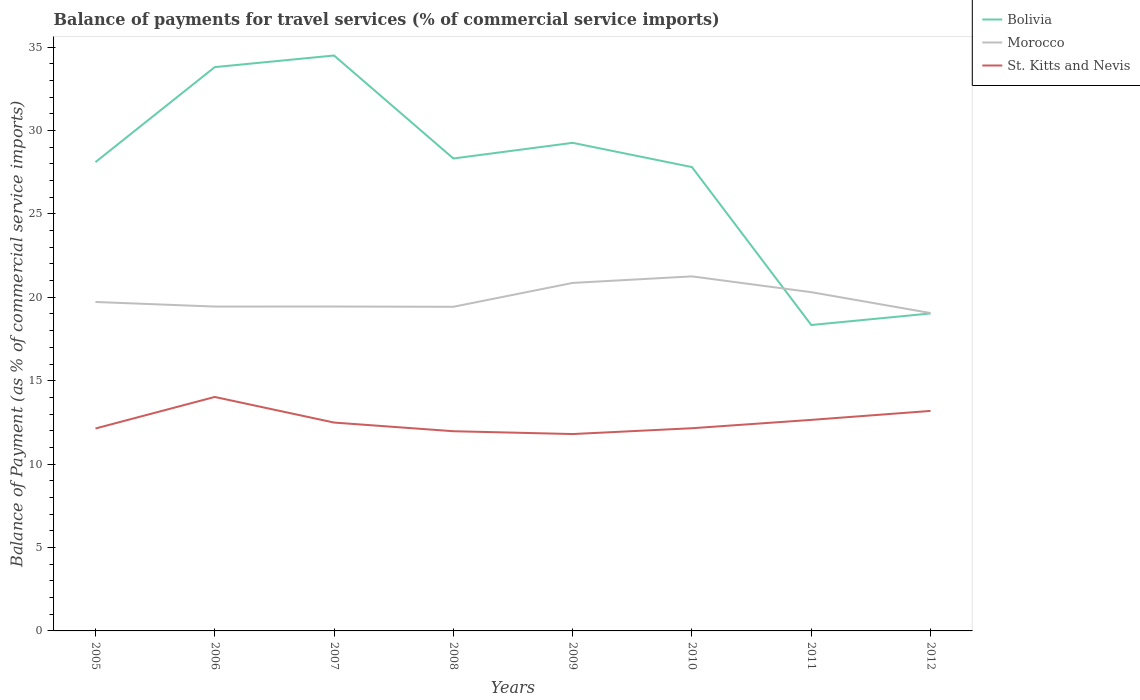Is the number of lines equal to the number of legend labels?
Your answer should be compact. Yes. Across all years, what is the maximum balance of payments for travel services in Bolivia?
Keep it short and to the point. 18.34. In which year was the balance of payments for travel services in St. Kitts and Nevis maximum?
Offer a terse response. 2009. What is the total balance of payments for travel services in Morocco in the graph?
Ensure brevity in your answer.  -0.86. What is the difference between the highest and the second highest balance of payments for travel services in St. Kitts and Nevis?
Offer a terse response. 2.22. What is the difference between the highest and the lowest balance of payments for travel services in St. Kitts and Nevis?
Keep it short and to the point. 3. What is the difference between two consecutive major ticks on the Y-axis?
Ensure brevity in your answer.  5. Are the values on the major ticks of Y-axis written in scientific E-notation?
Provide a short and direct response. No. Does the graph contain grids?
Keep it short and to the point. No. Where does the legend appear in the graph?
Ensure brevity in your answer.  Top right. How many legend labels are there?
Your answer should be compact. 3. How are the legend labels stacked?
Give a very brief answer. Vertical. What is the title of the graph?
Make the answer very short. Balance of payments for travel services (% of commercial service imports). Does "World" appear as one of the legend labels in the graph?
Your answer should be compact. No. What is the label or title of the X-axis?
Your response must be concise. Years. What is the label or title of the Y-axis?
Ensure brevity in your answer.  Balance of Payment (as % of commercial service imports). What is the Balance of Payment (as % of commercial service imports) of Bolivia in 2005?
Your answer should be compact. 28.1. What is the Balance of Payment (as % of commercial service imports) of Morocco in 2005?
Provide a succinct answer. 19.72. What is the Balance of Payment (as % of commercial service imports) of St. Kitts and Nevis in 2005?
Provide a short and direct response. 12.13. What is the Balance of Payment (as % of commercial service imports) in Bolivia in 2006?
Offer a very short reply. 33.8. What is the Balance of Payment (as % of commercial service imports) in Morocco in 2006?
Provide a succinct answer. 19.44. What is the Balance of Payment (as % of commercial service imports) in St. Kitts and Nevis in 2006?
Keep it short and to the point. 14.03. What is the Balance of Payment (as % of commercial service imports) of Bolivia in 2007?
Your answer should be compact. 34.49. What is the Balance of Payment (as % of commercial service imports) in Morocco in 2007?
Offer a very short reply. 19.45. What is the Balance of Payment (as % of commercial service imports) in St. Kitts and Nevis in 2007?
Provide a succinct answer. 12.49. What is the Balance of Payment (as % of commercial service imports) in Bolivia in 2008?
Your response must be concise. 28.32. What is the Balance of Payment (as % of commercial service imports) in Morocco in 2008?
Offer a terse response. 19.43. What is the Balance of Payment (as % of commercial service imports) of St. Kitts and Nevis in 2008?
Provide a short and direct response. 11.97. What is the Balance of Payment (as % of commercial service imports) in Bolivia in 2009?
Your answer should be compact. 29.26. What is the Balance of Payment (as % of commercial service imports) of Morocco in 2009?
Your answer should be compact. 20.86. What is the Balance of Payment (as % of commercial service imports) of St. Kitts and Nevis in 2009?
Ensure brevity in your answer.  11.8. What is the Balance of Payment (as % of commercial service imports) of Bolivia in 2010?
Ensure brevity in your answer.  27.8. What is the Balance of Payment (as % of commercial service imports) of Morocco in 2010?
Make the answer very short. 21.25. What is the Balance of Payment (as % of commercial service imports) in St. Kitts and Nevis in 2010?
Your response must be concise. 12.15. What is the Balance of Payment (as % of commercial service imports) in Bolivia in 2011?
Provide a succinct answer. 18.34. What is the Balance of Payment (as % of commercial service imports) in Morocco in 2011?
Offer a very short reply. 20.31. What is the Balance of Payment (as % of commercial service imports) in St. Kitts and Nevis in 2011?
Your answer should be very brief. 12.65. What is the Balance of Payment (as % of commercial service imports) of Bolivia in 2012?
Give a very brief answer. 19.03. What is the Balance of Payment (as % of commercial service imports) of Morocco in 2012?
Your response must be concise. 19.06. What is the Balance of Payment (as % of commercial service imports) in St. Kitts and Nevis in 2012?
Make the answer very short. 13.19. Across all years, what is the maximum Balance of Payment (as % of commercial service imports) of Bolivia?
Offer a very short reply. 34.49. Across all years, what is the maximum Balance of Payment (as % of commercial service imports) of Morocco?
Offer a terse response. 21.25. Across all years, what is the maximum Balance of Payment (as % of commercial service imports) of St. Kitts and Nevis?
Give a very brief answer. 14.03. Across all years, what is the minimum Balance of Payment (as % of commercial service imports) of Bolivia?
Offer a terse response. 18.34. Across all years, what is the minimum Balance of Payment (as % of commercial service imports) of Morocco?
Offer a very short reply. 19.06. Across all years, what is the minimum Balance of Payment (as % of commercial service imports) in St. Kitts and Nevis?
Make the answer very short. 11.8. What is the total Balance of Payment (as % of commercial service imports) in Bolivia in the graph?
Give a very brief answer. 219.15. What is the total Balance of Payment (as % of commercial service imports) in Morocco in the graph?
Give a very brief answer. 159.51. What is the total Balance of Payment (as % of commercial service imports) of St. Kitts and Nevis in the graph?
Make the answer very short. 100.41. What is the difference between the Balance of Payment (as % of commercial service imports) of Bolivia in 2005 and that in 2006?
Give a very brief answer. -5.69. What is the difference between the Balance of Payment (as % of commercial service imports) of Morocco in 2005 and that in 2006?
Offer a terse response. 0.27. What is the difference between the Balance of Payment (as % of commercial service imports) in St. Kitts and Nevis in 2005 and that in 2006?
Offer a very short reply. -1.89. What is the difference between the Balance of Payment (as % of commercial service imports) of Bolivia in 2005 and that in 2007?
Provide a short and direct response. -6.39. What is the difference between the Balance of Payment (as % of commercial service imports) of Morocco in 2005 and that in 2007?
Offer a very short reply. 0.27. What is the difference between the Balance of Payment (as % of commercial service imports) in St. Kitts and Nevis in 2005 and that in 2007?
Ensure brevity in your answer.  -0.36. What is the difference between the Balance of Payment (as % of commercial service imports) of Bolivia in 2005 and that in 2008?
Provide a short and direct response. -0.22. What is the difference between the Balance of Payment (as % of commercial service imports) of Morocco in 2005 and that in 2008?
Your answer should be compact. 0.29. What is the difference between the Balance of Payment (as % of commercial service imports) in St. Kitts and Nevis in 2005 and that in 2008?
Your answer should be very brief. 0.16. What is the difference between the Balance of Payment (as % of commercial service imports) in Bolivia in 2005 and that in 2009?
Provide a succinct answer. -1.15. What is the difference between the Balance of Payment (as % of commercial service imports) in Morocco in 2005 and that in 2009?
Your answer should be very brief. -1.14. What is the difference between the Balance of Payment (as % of commercial service imports) of Bolivia in 2005 and that in 2010?
Your answer should be compact. 0.3. What is the difference between the Balance of Payment (as % of commercial service imports) in Morocco in 2005 and that in 2010?
Offer a very short reply. -1.53. What is the difference between the Balance of Payment (as % of commercial service imports) in St. Kitts and Nevis in 2005 and that in 2010?
Give a very brief answer. -0.02. What is the difference between the Balance of Payment (as % of commercial service imports) in Bolivia in 2005 and that in 2011?
Your answer should be very brief. 9.77. What is the difference between the Balance of Payment (as % of commercial service imports) of Morocco in 2005 and that in 2011?
Your answer should be compact. -0.59. What is the difference between the Balance of Payment (as % of commercial service imports) of St. Kitts and Nevis in 2005 and that in 2011?
Offer a very short reply. -0.52. What is the difference between the Balance of Payment (as % of commercial service imports) in Bolivia in 2005 and that in 2012?
Offer a very short reply. 9.07. What is the difference between the Balance of Payment (as % of commercial service imports) in Morocco in 2005 and that in 2012?
Offer a terse response. 0.66. What is the difference between the Balance of Payment (as % of commercial service imports) in St. Kitts and Nevis in 2005 and that in 2012?
Your answer should be very brief. -1.05. What is the difference between the Balance of Payment (as % of commercial service imports) of Bolivia in 2006 and that in 2007?
Your answer should be compact. -0.7. What is the difference between the Balance of Payment (as % of commercial service imports) of Morocco in 2006 and that in 2007?
Give a very brief answer. -0. What is the difference between the Balance of Payment (as % of commercial service imports) in St. Kitts and Nevis in 2006 and that in 2007?
Give a very brief answer. 1.53. What is the difference between the Balance of Payment (as % of commercial service imports) in Bolivia in 2006 and that in 2008?
Your response must be concise. 5.48. What is the difference between the Balance of Payment (as % of commercial service imports) in Morocco in 2006 and that in 2008?
Give a very brief answer. 0.01. What is the difference between the Balance of Payment (as % of commercial service imports) of St. Kitts and Nevis in 2006 and that in 2008?
Your answer should be very brief. 2.05. What is the difference between the Balance of Payment (as % of commercial service imports) of Bolivia in 2006 and that in 2009?
Your answer should be compact. 4.54. What is the difference between the Balance of Payment (as % of commercial service imports) in Morocco in 2006 and that in 2009?
Keep it short and to the point. -1.42. What is the difference between the Balance of Payment (as % of commercial service imports) in St. Kitts and Nevis in 2006 and that in 2009?
Ensure brevity in your answer.  2.22. What is the difference between the Balance of Payment (as % of commercial service imports) in Bolivia in 2006 and that in 2010?
Ensure brevity in your answer.  5.99. What is the difference between the Balance of Payment (as % of commercial service imports) in Morocco in 2006 and that in 2010?
Your answer should be compact. -1.81. What is the difference between the Balance of Payment (as % of commercial service imports) in St. Kitts and Nevis in 2006 and that in 2010?
Your response must be concise. 1.87. What is the difference between the Balance of Payment (as % of commercial service imports) in Bolivia in 2006 and that in 2011?
Offer a very short reply. 15.46. What is the difference between the Balance of Payment (as % of commercial service imports) of Morocco in 2006 and that in 2011?
Give a very brief answer. -0.86. What is the difference between the Balance of Payment (as % of commercial service imports) of St. Kitts and Nevis in 2006 and that in 2011?
Your answer should be very brief. 1.37. What is the difference between the Balance of Payment (as % of commercial service imports) in Bolivia in 2006 and that in 2012?
Offer a terse response. 14.77. What is the difference between the Balance of Payment (as % of commercial service imports) of Morocco in 2006 and that in 2012?
Provide a succinct answer. 0.39. What is the difference between the Balance of Payment (as % of commercial service imports) in St. Kitts and Nevis in 2006 and that in 2012?
Your response must be concise. 0.84. What is the difference between the Balance of Payment (as % of commercial service imports) in Bolivia in 2007 and that in 2008?
Make the answer very short. 6.17. What is the difference between the Balance of Payment (as % of commercial service imports) of Morocco in 2007 and that in 2008?
Your answer should be very brief. 0.02. What is the difference between the Balance of Payment (as % of commercial service imports) in St. Kitts and Nevis in 2007 and that in 2008?
Make the answer very short. 0.52. What is the difference between the Balance of Payment (as % of commercial service imports) of Bolivia in 2007 and that in 2009?
Keep it short and to the point. 5.24. What is the difference between the Balance of Payment (as % of commercial service imports) of Morocco in 2007 and that in 2009?
Provide a short and direct response. -1.42. What is the difference between the Balance of Payment (as % of commercial service imports) in St. Kitts and Nevis in 2007 and that in 2009?
Your answer should be very brief. 0.69. What is the difference between the Balance of Payment (as % of commercial service imports) in Bolivia in 2007 and that in 2010?
Ensure brevity in your answer.  6.69. What is the difference between the Balance of Payment (as % of commercial service imports) of Morocco in 2007 and that in 2010?
Your answer should be compact. -1.81. What is the difference between the Balance of Payment (as % of commercial service imports) of St. Kitts and Nevis in 2007 and that in 2010?
Your response must be concise. 0.34. What is the difference between the Balance of Payment (as % of commercial service imports) of Bolivia in 2007 and that in 2011?
Ensure brevity in your answer.  16.15. What is the difference between the Balance of Payment (as % of commercial service imports) in Morocco in 2007 and that in 2011?
Keep it short and to the point. -0.86. What is the difference between the Balance of Payment (as % of commercial service imports) of St. Kitts and Nevis in 2007 and that in 2011?
Your answer should be compact. -0.16. What is the difference between the Balance of Payment (as % of commercial service imports) in Bolivia in 2007 and that in 2012?
Your answer should be very brief. 15.46. What is the difference between the Balance of Payment (as % of commercial service imports) in Morocco in 2007 and that in 2012?
Provide a short and direct response. 0.39. What is the difference between the Balance of Payment (as % of commercial service imports) in St. Kitts and Nevis in 2007 and that in 2012?
Offer a terse response. -0.7. What is the difference between the Balance of Payment (as % of commercial service imports) of Bolivia in 2008 and that in 2009?
Offer a terse response. -0.94. What is the difference between the Balance of Payment (as % of commercial service imports) of Morocco in 2008 and that in 2009?
Ensure brevity in your answer.  -1.43. What is the difference between the Balance of Payment (as % of commercial service imports) in St. Kitts and Nevis in 2008 and that in 2009?
Your response must be concise. 0.17. What is the difference between the Balance of Payment (as % of commercial service imports) in Bolivia in 2008 and that in 2010?
Your answer should be compact. 0.52. What is the difference between the Balance of Payment (as % of commercial service imports) in Morocco in 2008 and that in 2010?
Provide a short and direct response. -1.82. What is the difference between the Balance of Payment (as % of commercial service imports) in St. Kitts and Nevis in 2008 and that in 2010?
Offer a terse response. -0.18. What is the difference between the Balance of Payment (as % of commercial service imports) in Bolivia in 2008 and that in 2011?
Your answer should be very brief. 9.98. What is the difference between the Balance of Payment (as % of commercial service imports) in Morocco in 2008 and that in 2011?
Keep it short and to the point. -0.88. What is the difference between the Balance of Payment (as % of commercial service imports) of St. Kitts and Nevis in 2008 and that in 2011?
Provide a short and direct response. -0.68. What is the difference between the Balance of Payment (as % of commercial service imports) of Bolivia in 2008 and that in 2012?
Your answer should be very brief. 9.29. What is the difference between the Balance of Payment (as % of commercial service imports) of Morocco in 2008 and that in 2012?
Provide a short and direct response. 0.37. What is the difference between the Balance of Payment (as % of commercial service imports) in St. Kitts and Nevis in 2008 and that in 2012?
Give a very brief answer. -1.22. What is the difference between the Balance of Payment (as % of commercial service imports) in Bolivia in 2009 and that in 2010?
Provide a succinct answer. 1.45. What is the difference between the Balance of Payment (as % of commercial service imports) of Morocco in 2009 and that in 2010?
Provide a succinct answer. -0.39. What is the difference between the Balance of Payment (as % of commercial service imports) in St. Kitts and Nevis in 2009 and that in 2010?
Offer a terse response. -0.35. What is the difference between the Balance of Payment (as % of commercial service imports) of Bolivia in 2009 and that in 2011?
Keep it short and to the point. 10.92. What is the difference between the Balance of Payment (as % of commercial service imports) in Morocco in 2009 and that in 2011?
Your answer should be very brief. 0.55. What is the difference between the Balance of Payment (as % of commercial service imports) of St. Kitts and Nevis in 2009 and that in 2011?
Your answer should be very brief. -0.85. What is the difference between the Balance of Payment (as % of commercial service imports) in Bolivia in 2009 and that in 2012?
Ensure brevity in your answer.  10.23. What is the difference between the Balance of Payment (as % of commercial service imports) in Morocco in 2009 and that in 2012?
Give a very brief answer. 1.8. What is the difference between the Balance of Payment (as % of commercial service imports) in St. Kitts and Nevis in 2009 and that in 2012?
Your answer should be compact. -1.39. What is the difference between the Balance of Payment (as % of commercial service imports) in Bolivia in 2010 and that in 2011?
Make the answer very short. 9.47. What is the difference between the Balance of Payment (as % of commercial service imports) in Morocco in 2010 and that in 2011?
Ensure brevity in your answer.  0.95. What is the difference between the Balance of Payment (as % of commercial service imports) of Bolivia in 2010 and that in 2012?
Offer a terse response. 8.77. What is the difference between the Balance of Payment (as % of commercial service imports) in Morocco in 2010 and that in 2012?
Offer a terse response. 2.2. What is the difference between the Balance of Payment (as % of commercial service imports) of St. Kitts and Nevis in 2010 and that in 2012?
Your answer should be very brief. -1.04. What is the difference between the Balance of Payment (as % of commercial service imports) in Bolivia in 2011 and that in 2012?
Give a very brief answer. -0.69. What is the difference between the Balance of Payment (as % of commercial service imports) of Morocco in 2011 and that in 2012?
Offer a terse response. 1.25. What is the difference between the Balance of Payment (as % of commercial service imports) in St. Kitts and Nevis in 2011 and that in 2012?
Offer a terse response. -0.54. What is the difference between the Balance of Payment (as % of commercial service imports) of Bolivia in 2005 and the Balance of Payment (as % of commercial service imports) of Morocco in 2006?
Offer a terse response. 8.66. What is the difference between the Balance of Payment (as % of commercial service imports) of Bolivia in 2005 and the Balance of Payment (as % of commercial service imports) of St. Kitts and Nevis in 2006?
Provide a short and direct response. 14.08. What is the difference between the Balance of Payment (as % of commercial service imports) of Morocco in 2005 and the Balance of Payment (as % of commercial service imports) of St. Kitts and Nevis in 2006?
Your answer should be very brief. 5.69. What is the difference between the Balance of Payment (as % of commercial service imports) of Bolivia in 2005 and the Balance of Payment (as % of commercial service imports) of Morocco in 2007?
Your answer should be compact. 8.66. What is the difference between the Balance of Payment (as % of commercial service imports) in Bolivia in 2005 and the Balance of Payment (as % of commercial service imports) in St. Kitts and Nevis in 2007?
Your answer should be very brief. 15.61. What is the difference between the Balance of Payment (as % of commercial service imports) in Morocco in 2005 and the Balance of Payment (as % of commercial service imports) in St. Kitts and Nevis in 2007?
Offer a terse response. 7.23. What is the difference between the Balance of Payment (as % of commercial service imports) of Bolivia in 2005 and the Balance of Payment (as % of commercial service imports) of Morocco in 2008?
Give a very brief answer. 8.67. What is the difference between the Balance of Payment (as % of commercial service imports) of Bolivia in 2005 and the Balance of Payment (as % of commercial service imports) of St. Kitts and Nevis in 2008?
Give a very brief answer. 16.13. What is the difference between the Balance of Payment (as % of commercial service imports) of Morocco in 2005 and the Balance of Payment (as % of commercial service imports) of St. Kitts and Nevis in 2008?
Your response must be concise. 7.75. What is the difference between the Balance of Payment (as % of commercial service imports) of Bolivia in 2005 and the Balance of Payment (as % of commercial service imports) of Morocco in 2009?
Make the answer very short. 7.24. What is the difference between the Balance of Payment (as % of commercial service imports) in Bolivia in 2005 and the Balance of Payment (as % of commercial service imports) in St. Kitts and Nevis in 2009?
Keep it short and to the point. 16.3. What is the difference between the Balance of Payment (as % of commercial service imports) of Morocco in 2005 and the Balance of Payment (as % of commercial service imports) of St. Kitts and Nevis in 2009?
Give a very brief answer. 7.92. What is the difference between the Balance of Payment (as % of commercial service imports) of Bolivia in 2005 and the Balance of Payment (as % of commercial service imports) of Morocco in 2010?
Give a very brief answer. 6.85. What is the difference between the Balance of Payment (as % of commercial service imports) of Bolivia in 2005 and the Balance of Payment (as % of commercial service imports) of St. Kitts and Nevis in 2010?
Your answer should be compact. 15.95. What is the difference between the Balance of Payment (as % of commercial service imports) in Morocco in 2005 and the Balance of Payment (as % of commercial service imports) in St. Kitts and Nevis in 2010?
Your answer should be compact. 7.57. What is the difference between the Balance of Payment (as % of commercial service imports) of Bolivia in 2005 and the Balance of Payment (as % of commercial service imports) of Morocco in 2011?
Offer a terse response. 7.8. What is the difference between the Balance of Payment (as % of commercial service imports) of Bolivia in 2005 and the Balance of Payment (as % of commercial service imports) of St. Kitts and Nevis in 2011?
Your response must be concise. 15.45. What is the difference between the Balance of Payment (as % of commercial service imports) of Morocco in 2005 and the Balance of Payment (as % of commercial service imports) of St. Kitts and Nevis in 2011?
Your answer should be compact. 7.07. What is the difference between the Balance of Payment (as % of commercial service imports) in Bolivia in 2005 and the Balance of Payment (as % of commercial service imports) in Morocco in 2012?
Offer a terse response. 9.05. What is the difference between the Balance of Payment (as % of commercial service imports) of Bolivia in 2005 and the Balance of Payment (as % of commercial service imports) of St. Kitts and Nevis in 2012?
Your response must be concise. 14.92. What is the difference between the Balance of Payment (as % of commercial service imports) of Morocco in 2005 and the Balance of Payment (as % of commercial service imports) of St. Kitts and Nevis in 2012?
Your response must be concise. 6.53. What is the difference between the Balance of Payment (as % of commercial service imports) of Bolivia in 2006 and the Balance of Payment (as % of commercial service imports) of Morocco in 2007?
Your answer should be very brief. 14.35. What is the difference between the Balance of Payment (as % of commercial service imports) in Bolivia in 2006 and the Balance of Payment (as % of commercial service imports) in St. Kitts and Nevis in 2007?
Ensure brevity in your answer.  21.31. What is the difference between the Balance of Payment (as % of commercial service imports) in Morocco in 2006 and the Balance of Payment (as % of commercial service imports) in St. Kitts and Nevis in 2007?
Ensure brevity in your answer.  6.95. What is the difference between the Balance of Payment (as % of commercial service imports) of Bolivia in 2006 and the Balance of Payment (as % of commercial service imports) of Morocco in 2008?
Provide a succinct answer. 14.37. What is the difference between the Balance of Payment (as % of commercial service imports) of Bolivia in 2006 and the Balance of Payment (as % of commercial service imports) of St. Kitts and Nevis in 2008?
Your response must be concise. 21.83. What is the difference between the Balance of Payment (as % of commercial service imports) in Morocco in 2006 and the Balance of Payment (as % of commercial service imports) in St. Kitts and Nevis in 2008?
Offer a terse response. 7.47. What is the difference between the Balance of Payment (as % of commercial service imports) in Bolivia in 2006 and the Balance of Payment (as % of commercial service imports) in Morocco in 2009?
Offer a terse response. 12.94. What is the difference between the Balance of Payment (as % of commercial service imports) in Bolivia in 2006 and the Balance of Payment (as % of commercial service imports) in St. Kitts and Nevis in 2009?
Your answer should be compact. 22. What is the difference between the Balance of Payment (as % of commercial service imports) in Morocco in 2006 and the Balance of Payment (as % of commercial service imports) in St. Kitts and Nevis in 2009?
Your response must be concise. 7.64. What is the difference between the Balance of Payment (as % of commercial service imports) of Bolivia in 2006 and the Balance of Payment (as % of commercial service imports) of Morocco in 2010?
Give a very brief answer. 12.54. What is the difference between the Balance of Payment (as % of commercial service imports) in Bolivia in 2006 and the Balance of Payment (as % of commercial service imports) in St. Kitts and Nevis in 2010?
Offer a terse response. 21.65. What is the difference between the Balance of Payment (as % of commercial service imports) in Morocco in 2006 and the Balance of Payment (as % of commercial service imports) in St. Kitts and Nevis in 2010?
Keep it short and to the point. 7.29. What is the difference between the Balance of Payment (as % of commercial service imports) of Bolivia in 2006 and the Balance of Payment (as % of commercial service imports) of Morocco in 2011?
Provide a short and direct response. 13.49. What is the difference between the Balance of Payment (as % of commercial service imports) in Bolivia in 2006 and the Balance of Payment (as % of commercial service imports) in St. Kitts and Nevis in 2011?
Provide a short and direct response. 21.15. What is the difference between the Balance of Payment (as % of commercial service imports) of Morocco in 2006 and the Balance of Payment (as % of commercial service imports) of St. Kitts and Nevis in 2011?
Ensure brevity in your answer.  6.79. What is the difference between the Balance of Payment (as % of commercial service imports) of Bolivia in 2006 and the Balance of Payment (as % of commercial service imports) of Morocco in 2012?
Give a very brief answer. 14.74. What is the difference between the Balance of Payment (as % of commercial service imports) of Bolivia in 2006 and the Balance of Payment (as % of commercial service imports) of St. Kitts and Nevis in 2012?
Give a very brief answer. 20.61. What is the difference between the Balance of Payment (as % of commercial service imports) in Morocco in 2006 and the Balance of Payment (as % of commercial service imports) in St. Kitts and Nevis in 2012?
Your answer should be compact. 6.26. What is the difference between the Balance of Payment (as % of commercial service imports) of Bolivia in 2007 and the Balance of Payment (as % of commercial service imports) of Morocco in 2008?
Offer a terse response. 15.06. What is the difference between the Balance of Payment (as % of commercial service imports) of Bolivia in 2007 and the Balance of Payment (as % of commercial service imports) of St. Kitts and Nevis in 2008?
Provide a short and direct response. 22.52. What is the difference between the Balance of Payment (as % of commercial service imports) of Morocco in 2007 and the Balance of Payment (as % of commercial service imports) of St. Kitts and Nevis in 2008?
Your answer should be compact. 7.47. What is the difference between the Balance of Payment (as % of commercial service imports) in Bolivia in 2007 and the Balance of Payment (as % of commercial service imports) in Morocco in 2009?
Your response must be concise. 13.63. What is the difference between the Balance of Payment (as % of commercial service imports) of Bolivia in 2007 and the Balance of Payment (as % of commercial service imports) of St. Kitts and Nevis in 2009?
Provide a short and direct response. 22.69. What is the difference between the Balance of Payment (as % of commercial service imports) of Morocco in 2007 and the Balance of Payment (as % of commercial service imports) of St. Kitts and Nevis in 2009?
Offer a very short reply. 7.64. What is the difference between the Balance of Payment (as % of commercial service imports) in Bolivia in 2007 and the Balance of Payment (as % of commercial service imports) in Morocco in 2010?
Your answer should be very brief. 13.24. What is the difference between the Balance of Payment (as % of commercial service imports) of Bolivia in 2007 and the Balance of Payment (as % of commercial service imports) of St. Kitts and Nevis in 2010?
Keep it short and to the point. 22.34. What is the difference between the Balance of Payment (as % of commercial service imports) in Morocco in 2007 and the Balance of Payment (as % of commercial service imports) in St. Kitts and Nevis in 2010?
Make the answer very short. 7.29. What is the difference between the Balance of Payment (as % of commercial service imports) in Bolivia in 2007 and the Balance of Payment (as % of commercial service imports) in Morocco in 2011?
Offer a very short reply. 14.19. What is the difference between the Balance of Payment (as % of commercial service imports) in Bolivia in 2007 and the Balance of Payment (as % of commercial service imports) in St. Kitts and Nevis in 2011?
Your response must be concise. 21.84. What is the difference between the Balance of Payment (as % of commercial service imports) in Morocco in 2007 and the Balance of Payment (as % of commercial service imports) in St. Kitts and Nevis in 2011?
Your response must be concise. 6.79. What is the difference between the Balance of Payment (as % of commercial service imports) of Bolivia in 2007 and the Balance of Payment (as % of commercial service imports) of Morocco in 2012?
Your response must be concise. 15.44. What is the difference between the Balance of Payment (as % of commercial service imports) of Bolivia in 2007 and the Balance of Payment (as % of commercial service imports) of St. Kitts and Nevis in 2012?
Provide a succinct answer. 21.31. What is the difference between the Balance of Payment (as % of commercial service imports) of Morocco in 2007 and the Balance of Payment (as % of commercial service imports) of St. Kitts and Nevis in 2012?
Offer a very short reply. 6.26. What is the difference between the Balance of Payment (as % of commercial service imports) of Bolivia in 2008 and the Balance of Payment (as % of commercial service imports) of Morocco in 2009?
Provide a short and direct response. 7.46. What is the difference between the Balance of Payment (as % of commercial service imports) in Bolivia in 2008 and the Balance of Payment (as % of commercial service imports) in St. Kitts and Nevis in 2009?
Keep it short and to the point. 16.52. What is the difference between the Balance of Payment (as % of commercial service imports) in Morocco in 2008 and the Balance of Payment (as % of commercial service imports) in St. Kitts and Nevis in 2009?
Provide a short and direct response. 7.63. What is the difference between the Balance of Payment (as % of commercial service imports) of Bolivia in 2008 and the Balance of Payment (as % of commercial service imports) of Morocco in 2010?
Offer a very short reply. 7.07. What is the difference between the Balance of Payment (as % of commercial service imports) of Bolivia in 2008 and the Balance of Payment (as % of commercial service imports) of St. Kitts and Nevis in 2010?
Offer a terse response. 16.17. What is the difference between the Balance of Payment (as % of commercial service imports) in Morocco in 2008 and the Balance of Payment (as % of commercial service imports) in St. Kitts and Nevis in 2010?
Your response must be concise. 7.28. What is the difference between the Balance of Payment (as % of commercial service imports) of Bolivia in 2008 and the Balance of Payment (as % of commercial service imports) of Morocco in 2011?
Keep it short and to the point. 8.01. What is the difference between the Balance of Payment (as % of commercial service imports) in Bolivia in 2008 and the Balance of Payment (as % of commercial service imports) in St. Kitts and Nevis in 2011?
Make the answer very short. 15.67. What is the difference between the Balance of Payment (as % of commercial service imports) in Morocco in 2008 and the Balance of Payment (as % of commercial service imports) in St. Kitts and Nevis in 2011?
Provide a succinct answer. 6.78. What is the difference between the Balance of Payment (as % of commercial service imports) of Bolivia in 2008 and the Balance of Payment (as % of commercial service imports) of Morocco in 2012?
Offer a very short reply. 9.26. What is the difference between the Balance of Payment (as % of commercial service imports) in Bolivia in 2008 and the Balance of Payment (as % of commercial service imports) in St. Kitts and Nevis in 2012?
Provide a short and direct response. 15.13. What is the difference between the Balance of Payment (as % of commercial service imports) in Morocco in 2008 and the Balance of Payment (as % of commercial service imports) in St. Kitts and Nevis in 2012?
Make the answer very short. 6.24. What is the difference between the Balance of Payment (as % of commercial service imports) in Bolivia in 2009 and the Balance of Payment (as % of commercial service imports) in Morocco in 2010?
Your answer should be compact. 8.01. What is the difference between the Balance of Payment (as % of commercial service imports) in Bolivia in 2009 and the Balance of Payment (as % of commercial service imports) in St. Kitts and Nevis in 2010?
Keep it short and to the point. 17.11. What is the difference between the Balance of Payment (as % of commercial service imports) in Morocco in 2009 and the Balance of Payment (as % of commercial service imports) in St. Kitts and Nevis in 2010?
Provide a short and direct response. 8.71. What is the difference between the Balance of Payment (as % of commercial service imports) in Bolivia in 2009 and the Balance of Payment (as % of commercial service imports) in Morocco in 2011?
Keep it short and to the point. 8.95. What is the difference between the Balance of Payment (as % of commercial service imports) of Bolivia in 2009 and the Balance of Payment (as % of commercial service imports) of St. Kitts and Nevis in 2011?
Make the answer very short. 16.61. What is the difference between the Balance of Payment (as % of commercial service imports) of Morocco in 2009 and the Balance of Payment (as % of commercial service imports) of St. Kitts and Nevis in 2011?
Offer a very short reply. 8.21. What is the difference between the Balance of Payment (as % of commercial service imports) of Bolivia in 2009 and the Balance of Payment (as % of commercial service imports) of Morocco in 2012?
Offer a terse response. 10.2. What is the difference between the Balance of Payment (as % of commercial service imports) in Bolivia in 2009 and the Balance of Payment (as % of commercial service imports) in St. Kitts and Nevis in 2012?
Keep it short and to the point. 16.07. What is the difference between the Balance of Payment (as % of commercial service imports) in Morocco in 2009 and the Balance of Payment (as % of commercial service imports) in St. Kitts and Nevis in 2012?
Ensure brevity in your answer.  7.67. What is the difference between the Balance of Payment (as % of commercial service imports) of Bolivia in 2010 and the Balance of Payment (as % of commercial service imports) of Morocco in 2011?
Offer a very short reply. 7.5. What is the difference between the Balance of Payment (as % of commercial service imports) in Bolivia in 2010 and the Balance of Payment (as % of commercial service imports) in St. Kitts and Nevis in 2011?
Make the answer very short. 15.15. What is the difference between the Balance of Payment (as % of commercial service imports) of Morocco in 2010 and the Balance of Payment (as % of commercial service imports) of St. Kitts and Nevis in 2011?
Give a very brief answer. 8.6. What is the difference between the Balance of Payment (as % of commercial service imports) of Bolivia in 2010 and the Balance of Payment (as % of commercial service imports) of Morocco in 2012?
Ensure brevity in your answer.  8.75. What is the difference between the Balance of Payment (as % of commercial service imports) of Bolivia in 2010 and the Balance of Payment (as % of commercial service imports) of St. Kitts and Nevis in 2012?
Your answer should be compact. 14.62. What is the difference between the Balance of Payment (as % of commercial service imports) of Morocco in 2010 and the Balance of Payment (as % of commercial service imports) of St. Kitts and Nevis in 2012?
Give a very brief answer. 8.06. What is the difference between the Balance of Payment (as % of commercial service imports) of Bolivia in 2011 and the Balance of Payment (as % of commercial service imports) of Morocco in 2012?
Give a very brief answer. -0.72. What is the difference between the Balance of Payment (as % of commercial service imports) in Bolivia in 2011 and the Balance of Payment (as % of commercial service imports) in St. Kitts and Nevis in 2012?
Your response must be concise. 5.15. What is the difference between the Balance of Payment (as % of commercial service imports) of Morocco in 2011 and the Balance of Payment (as % of commercial service imports) of St. Kitts and Nevis in 2012?
Offer a very short reply. 7.12. What is the average Balance of Payment (as % of commercial service imports) of Bolivia per year?
Provide a succinct answer. 27.39. What is the average Balance of Payment (as % of commercial service imports) of Morocco per year?
Offer a terse response. 19.94. What is the average Balance of Payment (as % of commercial service imports) of St. Kitts and Nevis per year?
Provide a succinct answer. 12.55. In the year 2005, what is the difference between the Balance of Payment (as % of commercial service imports) of Bolivia and Balance of Payment (as % of commercial service imports) of Morocco?
Your answer should be very brief. 8.39. In the year 2005, what is the difference between the Balance of Payment (as % of commercial service imports) in Bolivia and Balance of Payment (as % of commercial service imports) in St. Kitts and Nevis?
Provide a short and direct response. 15.97. In the year 2005, what is the difference between the Balance of Payment (as % of commercial service imports) in Morocco and Balance of Payment (as % of commercial service imports) in St. Kitts and Nevis?
Your response must be concise. 7.58. In the year 2006, what is the difference between the Balance of Payment (as % of commercial service imports) in Bolivia and Balance of Payment (as % of commercial service imports) in Morocco?
Provide a succinct answer. 14.35. In the year 2006, what is the difference between the Balance of Payment (as % of commercial service imports) of Bolivia and Balance of Payment (as % of commercial service imports) of St. Kitts and Nevis?
Make the answer very short. 19.77. In the year 2006, what is the difference between the Balance of Payment (as % of commercial service imports) in Morocco and Balance of Payment (as % of commercial service imports) in St. Kitts and Nevis?
Ensure brevity in your answer.  5.42. In the year 2007, what is the difference between the Balance of Payment (as % of commercial service imports) in Bolivia and Balance of Payment (as % of commercial service imports) in Morocco?
Ensure brevity in your answer.  15.05. In the year 2007, what is the difference between the Balance of Payment (as % of commercial service imports) of Bolivia and Balance of Payment (as % of commercial service imports) of St. Kitts and Nevis?
Give a very brief answer. 22. In the year 2007, what is the difference between the Balance of Payment (as % of commercial service imports) in Morocco and Balance of Payment (as % of commercial service imports) in St. Kitts and Nevis?
Provide a succinct answer. 6.95. In the year 2008, what is the difference between the Balance of Payment (as % of commercial service imports) of Bolivia and Balance of Payment (as % of commercial service imports) of Morocco?
Keep it short and to the point. 8.89. In the year 2008, what is the difference between the Balance of Payment (as % of commercial service imports) of Bolivia and Balance of Payment (as % of commercial service imports) of St. Kitts and Nevis?
Make the answer very short. 16.35. In the year 2008, what is the difference between the Balance of Payment (as % of commercial service imports) of Morocco and Balance of Payment (as % of commercial service imports) of St. Kitts and Nevis?
Give a very brief answer. 7.46. In the year 2009, what is the difference between the Balance of Payment (as % of commercial service imports) of Bolivia and Balance of Payment (as % of commercial service imports) of Morocco?
Keep it short and to the point. 8.4. In the year 2009, what is the difference between the Balance of Payment (as % of commercial service imports) of Bolivia and Balance of Payment (as % of commercial service imports) of St. Kitts and Nevis?
Ensure brevity in your answer.  17.46. In the year 2009, what is the difference between the Balance of Payment (as % of commercial service imports) in Morocco and Balance of Payment (as % of commercial service imports) in St. Kitts and Nevis?
Your answer should be compact. 9.06. In the year 2010, what is the difference between the Balance of Payment (as % of commercial service imports) of Bolivia and Balance of Payment (as % of commercial service imports) of Morocco?
Your answer should be compact. 6.55. In the year 2010, what is the difference between the Balance of Payment (as % of commercial service imports) in Bolivia and Balance of Payment (as % of commercial service imports) in St. Kitts and Nevis?
Make the answer very short. 15.65. In the year 2010, what is the difference between the Balance of Payment (as % of commercial service imports) of Morocco and Balance of Payment (as % of commercial service imports) of St. Kitts and Nevis?
Offer a very short reply. 9.1. In the year 2011, what is the difference between the Balance of Payment (as % of commercial service imports) of Bolivia and Balance of Payment (as % of commercial service imports) of Morocco?
Keep it short and to the point. -1.97. In the year 2011, what is the difference between the Balance of Payment (as % of commercial service imports) of Bolivia and Balance of Payment (as % of commercial service imports) of St. Kitts and Nevis?
Ensure brevity in your answer.  5.69. In the year 2011, what is the difference between the Balance of Payment (as % of commercial service imports) of Morocco and Balance of Payment (as % of commercial service imports) of St. Kitts and Nevis?
Your answer should be very brief. 7.66. In the year 2012, what is the difference between the Balance of Payment (as % of commercial service imports) in Bolivia and Balance of Payment (as % of commercial service imports) in Morocco?
Your answer should be very brief. -0.03. In the year 2012, what is the difference between the Balance of Payment (as % of commercial service imports) of Bolivia and Balance of Payment (as % of commercial service imports) of St. Kitts and Nevis?
Provide a short and direct response. 5.84. In the year 2012, what is the difference between the Balance of Payment (as % of commercial service imports) in Morocco and Balance of Payment (as % of commercial service imports) in St. Kitts and Nevis?
Offer a very short reply. 5.87. What is the ratio of the Balance of Payment (as % of commercial service imports) of Bolivia in 2005 to that in 2006?
Keep it short and to the point. 0.83. What is the ratio of the Balance of Payment (as % of commercial service imports) in Morocco in 2005 to that in 2006?
Make the answer very short. 1.01. What is the ratio of the Balance of Payment (as % of commercial service imports) in St. Kitts and Nevis in 2005 to that in 2006?
Your response must be concise. 0.87. What is the ratio of the Balance of Payment (as % of commercial service imports) of Bolivia in 2005 to that in 2007?
Provide a succinct answer. 0.81. What is the ratio of the Balance of Payment (as % of commercial service imports) in Morocco in 2005 to that in 2007?
Your answer should be compact. 1.01. What is the ratio of the Balance of Payment (as % of commercial service imports) of St. Kitts and Nevis in 2005 to that in 2007?
Offer a terse response. 0.97. What is the ratio of the Balance of Payment (as % of commercial service imports) of Morocco in 2005 to that in 2008?
Your answer should be very brief. 1.01. What is the ratio of the Balance of Payment (as % of commercial service imports) of St. Kitts and Nevis in 2005 to that in 2008?
Your answer should be very brief. 1.01. What is the ratio of the Balance of Payment (as % of commercial service imports) in Bolivia in 2005 to that in 2009?
Offer a terse response. 0.96. What is the ratio of the Balance of Payment (as % of commercial service imports) in Morocco in 2005 to that in 2009?
Give a very brief answer. 0.95. What is the ratio of the Balance of Payment (as % of commercial service imports) of St. Kitts and Nevis in 2005 to that in 2009?
Offer a terse response. 1.03. What is the ratio of the Balance of Payment (as % of commercial service imports) of Bolivia in 2005 to that in 2010?
Offer a terse response. 1.01. What is the ratio of the Balance of Payment (as % of commercial service imports) of Morocco in 2005 to that in 2010?
Ensure brevity in your answer.  0.93. What is the ratio of the Balance of Payment (as % of commercial service imports) of Bolivia in 2005 to that in 2011?
Your answer should be very brief. 1.53. What is the ratio of the Balance of Payment (as % of commercial service imports) of St. Kitts and Nevis in 2005 to that in 2011?
Your answer should be compact. 0.96. What is the ratio of the Balance of Payment (as % of commercial service imports) of Bolivia in 2005 to that in 2012?
Your answer should be very brief. 1.48. What is the ratio of the Balance of Payment (as % of commercial service imports) in Morocco in 2005 to that in 2012?
Ensure brevity in your answer.  1.03. What is the ratio of the Balance of Payment (as % of commercial service imports) of St. Kitts and Nevis in 2005 to that in 2012?
Your response must be concise. 0.92. What is the ratio of the Balance of Payment (as % of commercial service imports) in Bolivia in 2006 to that in 2007?
Your response must be concise. 0.98. What is the ratio of the Balance of Payment (as % of commercial service imports) of Morocco in 2006 to that in 2007?
Keep it short and to the point. 1. What is the ratio of the Balance of Payment (as % of commercial service imports) of St. Kitts and Nevis in 2006 to that in 2007?
Ensure brevity in your answer.  1.12. What is the ratio of the Balance of Payment (as % of commercial service imports) in Bolivia in 2006 to that in 2008?
Make the answer very short. 1.19. What is the ratio of the Balance of Payment (as % of commercial service imports) of St. Kitts and Nevis in 2006 to that in 2008?
Your answer should be very brief. 1.17. What is the ratio of the Balance of Payment (as % of commercial service imports) in Bolivia in 2006 to that in 2009?
Provide a succinct answer. 1.16. What is the ratio of the Balance of Payment (as % of commercial service imports) of Morocco in 2006 to that in 2009?
Keep it short and to the point. 0.93. What is the ratio of the Balance of Payment (as % of commercial service imports) in St. Kitts and Nevis in 2006 to that in 2009?
Keep it short and to the point. 1.19. What is the ratio of the Balance of Payment (as % of commercial service imports) in Bolivia in 2006 to that in 2010?
Your response must be concise. 1.22. What is the ratio of the Balance of Payment (as % of commercial service imports) of Morocco in 2006 to that in 2010?
Ensure brevity in your answer.  0.91. What is the ratio of the Balance of Payment (as % of commercial service imports) of St. Kitts and Nevis in 2006 to that in 2010?
Keep it short and to the point. 1.15. What is the ratio of the Balance of Payment (as % of commercial service imports) of Bolivia in 2006 to that in 2011?
Your answer should be very brief. 1.84. What is the ratio of the Balance of Payment (as % of commercial service imports) in Morocco in 2006 to that in 2011?
Your answer should be very brief. 0.96. What is the ratio of the Balance of Payment (as % of commercial service imports) in St. Kitts and Nevis in 2006 to that in 2011?
Your answer should be compact. 1.11. What is the ratio of the Balance of Payment (as % of commercial service imports) of Bolivia in 2006 to that in 2012?
Provide a succinct answer. 1.78. What is the ratio of the Balance of Payment (as % of commercial service imports) of Morocco in 2006 to that in 2012?
Give a very brief answer. 1.02. What is the ratio of the Balance of Payment (as % of commercial service imports) of St. Kitts and Nevis in 2006 to that in 2012?
Make the answer very short. 1.06. What is the ratio of the Balance of Payment (as % of commercial service imports) in Bolivia in 2007 to that in 2008?
Make the answer very short. 1.22. What is the ratio of the Balance of Payment (as % of commercial service imports) in Morocco in 2007 to that in 2008?
Provide a short and direct response. 1. What is the ratio of the Balance of Payment (as % of commercial service imports) of St. Kitts and Nevis in 2007 to that in 2008?
Offer a terse response. 1.04. What is the ratio of the Balance of Payment (as % of commercial service imports) of Bolivia in 2007 to that in 2009?
Provide a short and direct response. 1.18. What is the ratio of the Balance of Payment (as % of commercial service imports) in Morocco in 2007 to that in 2009?
Make the answer very short. 0.93. What is the ratio of the Balance of Payment (as % of commercial service imports) in St. Kitts and Nevis in 2007 to that in 2009?
Ensure brevity in your answer.  1.06. What is the ratio of the Balance of Payment (as % of commercial service imports) of Bolivia in 2007 to that in 2010?
Offer a terse response. 1.24. What is the ratio of the Balance of Payment (as % of commercial service imports) of Morocco in 2007 to that in 2010?
Your answer should be compact. 0.91. What is the ratio of the Balance of Payment (as % of commercial service imports) in St. Kitts and Nevis in 2007 to that in 2010?
Provide a succinct answer. 1.03. What is the ratio of the Balance of Payment (as % of commercial service imports) in Bolivia in 2007 to that in 2011?
Make the answer very short. 1.88. What is the ratio of the Balance of Payment (as % of commercial service imports) of Morocco in 2007 to that in 2011?
Your response must be concise. 0.96. What is the ratio of the Balance of Payment (as % of commercial service imports) of St. Kitts and Nevis in 2007 to that in 2011?
Provide a short and direct response. 0.99. What is the ratio of the Balance of Payment (as % of commercial service imports) of Bolivia in 2007 to that in 2012?
Ensure brevity in your answer.  1.81. What is the ratio of the Balance of Payment (as % of commercial service imports) in Morocco in 2007 to that in 2012?
Offer a very short reply. 1.02. What is the ratio of the Balance of Payment (as % of commercial service imports) in St. Kitts and Nevis in 2007 to that in 2012?
Ensure brevity in your answer.  0.95. What is the ratio of the Balance of Payment (as % of commercial service imports) in Bolivia in 2008 to that in 2009?
Give a very brief answer. 0.97. What is the ratio of the Balance of Payment (as % of commercial service imports) of Morocco in 2008 to that in 2009?
Ensure brevity in your answer.  0.93. What is the ratio of the Balance of Payment (as % of commercial service imports) of St. Kitts and Nevis in 2008 to that in 2009?
Keep it short and to the point. 1.01. What is the ratio of the Balance of Payment (as % of commercial service imports) of Bolivia in 2008 to that in 2010?
Offer a terse response. 1.02. What is the ratio of the Balance of Payment (as % of commercial service imports) in Morocco in 2008 to that in 2010?
Offer a very short reply. 0.91. What is the ratio of the Balance of Payment (as % of commercial service imports) of St. Kitts and Nevis in 2008 to that in 2010?
Provide a succinct answer. 0.99. What is the ratio of the Balance of Payment (as % of commercial service imports) of Bolivia in 2008 to that in 2011?
Ensure brevity in your answer.  1.54. What is the ratio of the Balance of Payment (as % of commercial service imports) of Morocco in 2008 to that in 2011?
Offer a very short reply. 0.96. What is the ratio of the Balance of Payment (as % of commercial service imports) of St. Kitts and Nevis in 2008 to that in 2011?
Offer a terse response. 0.95. What is the ratio of the Balance of Payment (as % of commercial service imports) in Bolivia in 2008 to that in 2012?
Your answer should be compact. 1.49. What is the ratio of the Balance of Payment (as % of commercial service imports) of Morocco in 2008 to that in 2012?
Provide a short and direct response. 1.02. What is the ratio of the Balance of Payment (as % of commercial service imports) of St. Kitts and Nevis in 2008 to that in 2012?
Provide a succinct answer. 0.91. What is the ratio of the Balance of Payment (as % of commercial service imports) of Bolivia in 2009 to that in 2010?
Make the answer very short. 1.05. What is the ratio of the Balance of Payment (as % of commercial service imports) of Morocco in 2009 to that in 2010?
Offer a very short reply. 0.98. What is the ratio of the Balance of Payment (as % of commercial service imports) in St. Kitts and Nevis in 2009 to that in 2010?
Offer a terse response. 0.97. What is the ratio of the Balance of Payment (as % of commercial service imports) of Bolivia in 2009 to that in 2011?
Keep it short and to the point. 1.6. What is the ratio of the Balance of Payment (as % of commercial service imports) in Morocco in 2009 to that in 2011?
Ensure brevity in your answer.  1.03. What is the ratio of the Balance of Payment (as % of commercial service imports) in St. Kitts and Nevis in 2009 to that in 2011?
Provide a short and direct response. 0.93. What is the ratio of the Balance of Payment (as % of commercial service imports) of Bolivia in 2009 to that in 2012?
Offer a terse response. 1.54. What is the ratio of the Balance of Payment (as % of commercial service imports) in Morocco in 2009 to that in 2012?
Your answer should be compact. 1.09. What is the ratio of the Balance of Payment (as % of commercial service imports) in St. Kitts and Nevis in 2009 to that in 2012?
Keep it short and to the point. 0.89. What is the ratio of the Balance of Payment (as % of commercial service imports) of Bolivia in 2010 to that in 2011?
Give a very brief answer. 1.52. What is the ratio of the Balance of Payment (as % of commercial service imports) of Morocco in 2010 to that in 2011?
Offer a terse response. 1.05. What is the ratio of the Balance of Payment (as % of commercial service imports) in St. Kitts and Nevis in 2010 to that in 2011?
Your answer should be compact. 0.96. What is the ratio of the Balance of Payment (as % of commercial service imports) of Bolivia in 2010 to that in 2012?
Provide a succinct answer. 1.46. What is the ratio of the Balance of Payment (as % of commercial service imports) of Morocco in 2010 to that in 2012?
Provide a succinct answer. 1.12. What is the ratio of the Balance of Payment (as % of commercial service imports) in St. Kitts and Nevis in 2010 to that in 2012?
Offer a very short reply. 0.92. What is the ratio of the Balance of Payment (as % of commercial service imports) in Bolivia in 2011 to that in 2012?
Provide a short and direct response. 0.96. What is the ratio of the Balance of Payment (as % of commercial service imports) of Morocco in 2011 to that in 2012?
Give a very brief answer. 1.07. What is the ratio of the Balance of Payment (as % of commercial service imports) in St. Kitts and Nevis in 2011 to that in 2012?
Offer a terse response. 0.96. What is the difference between the highest and the second highest Balance of Payment (as % of commercial service imports) of Bolivia?
Your answer should be very brief. 0.7. What is the difference between the highest and the second highest Balance of Payment (as % of commercial service imports) in Morocco?
Provide a succinct answer. 0.39. What is the difference between the highest and the second highest Balance of Payment (as % of commercial service imports) of St. Kitts and Nevis?
Provide a short and direct response. 0.84. What is the difference between the highest and the lowest Balance of Payment (as % of commercial service imports) in Bolivia?
Offer a very short reply. 16.15. What is the difference between the highest and the lowest Balance of Payment (as % of commercial service imports) of Morocco?
Ensure brevity in your answer.  2.2. What is the difference between the highest and the lowest Balance of Payment (as % of commercial service imports) of St. Kitts and Nevis?
Your answer should be compact. 2.22. 